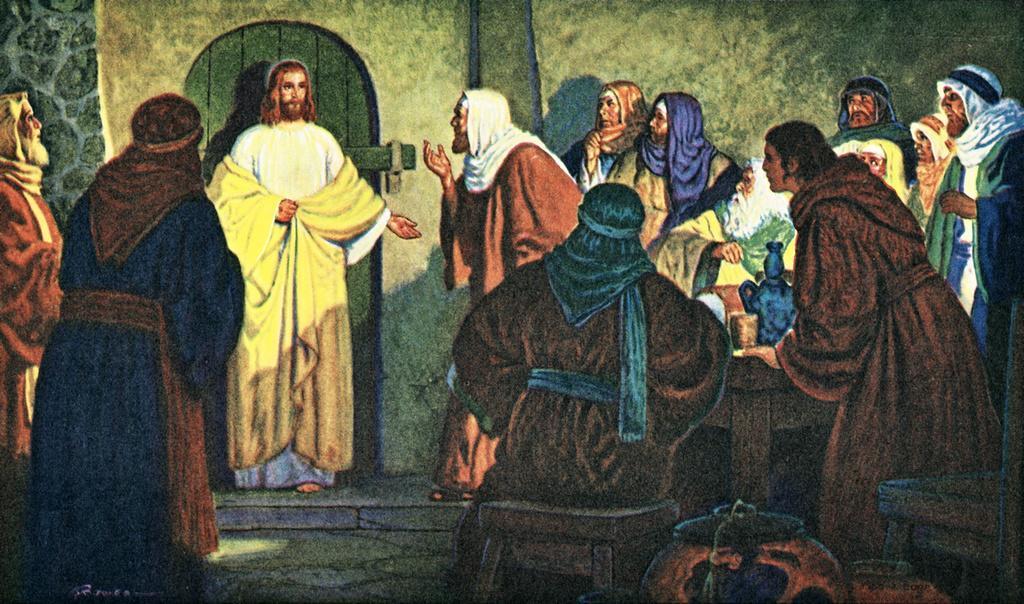Can you describe this image briefly? This is a picture of the painting, in this image we can see the group of people and a table with some objects on it, in the background, we can see a door and the wall. 